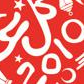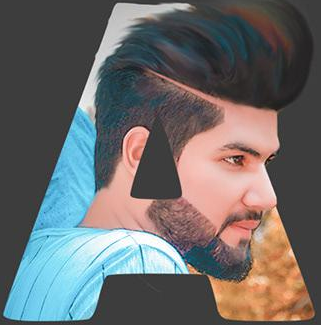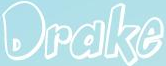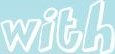Transcribe the words shown in these images in order, separated by a semicolon. 2010; A; Drake; with 